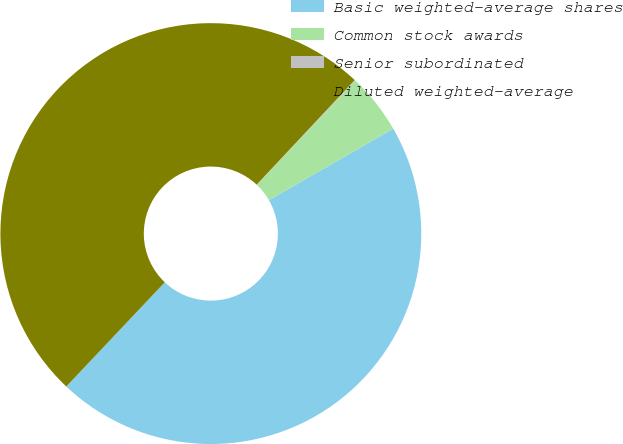<chart> <loc_0><loc_0><loc_500><loc_500><pie_chart><fcel>Basic weighted-average shares<fcel>Common stock awards<fcel>Senior subordinated<fcel>Diluted weighted-average<nl><fcel>45.36%<fcel>4.64%<fcel>0.07%<fcel>49.93%<nl></chart> 